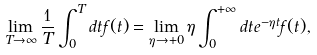Convert formula to latex. <formula><loc_0><loc_0><loc_500><loc_500>\lim _ { T \rightarrow \infty } \frac { 1 } { T } \int _ { 0 } ^ { T } d t f ( t ) = \lim _ { \eta \rightarrow + 0 } \eta \int _ { 0 } ^ { + \infty } d t e ^ { - \eta t } f ( t ) ,</formula> 